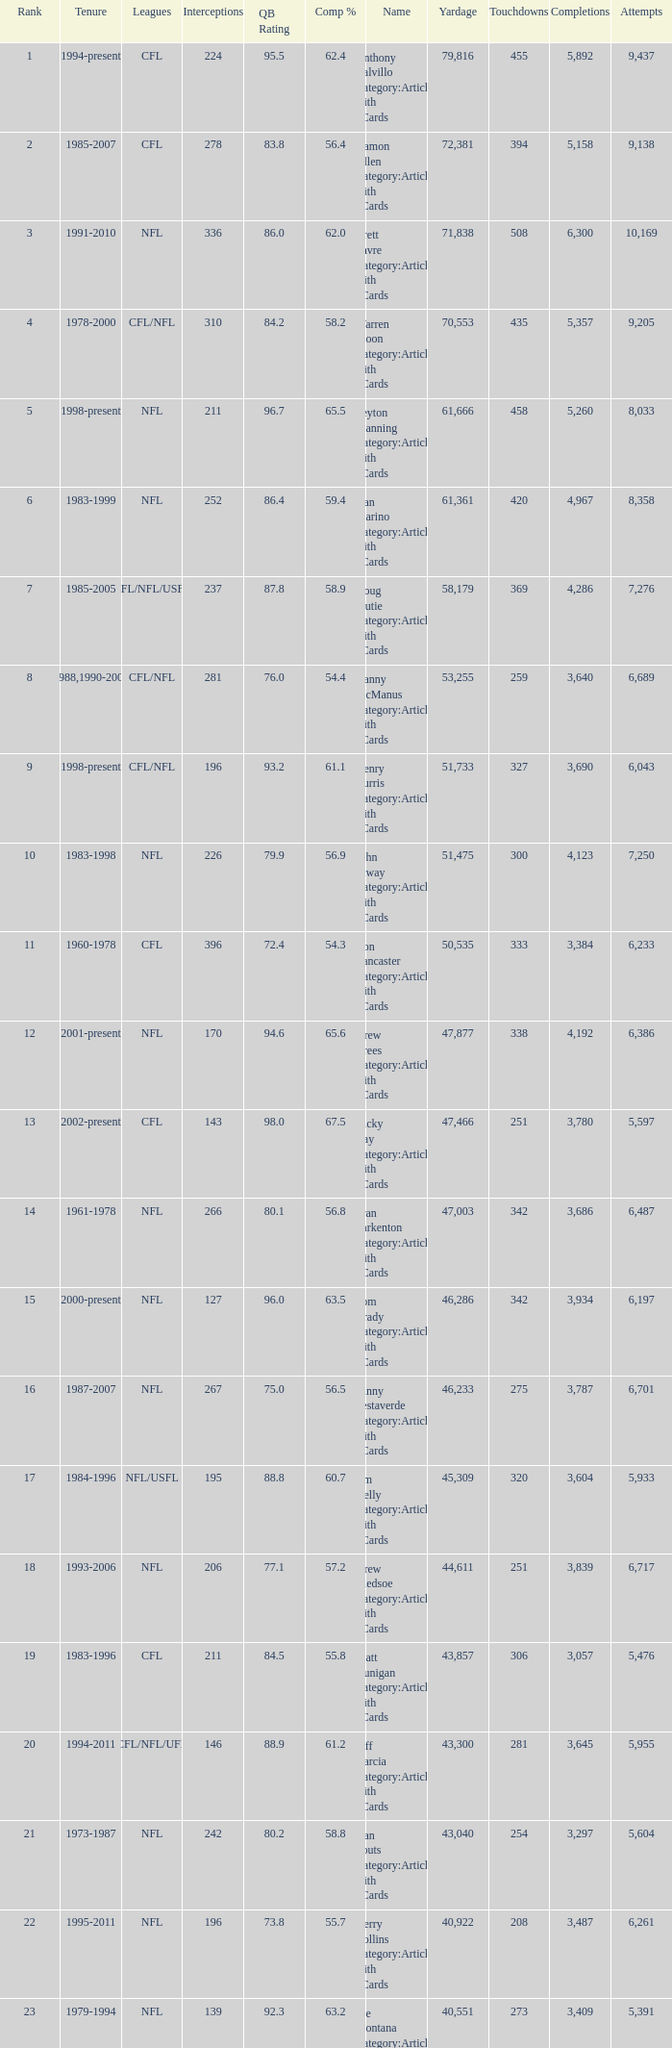What is the comp percentage when there are less than 44,611 in yardage, more than 254 touchdowns, and rank larger than 24? 54.6. 